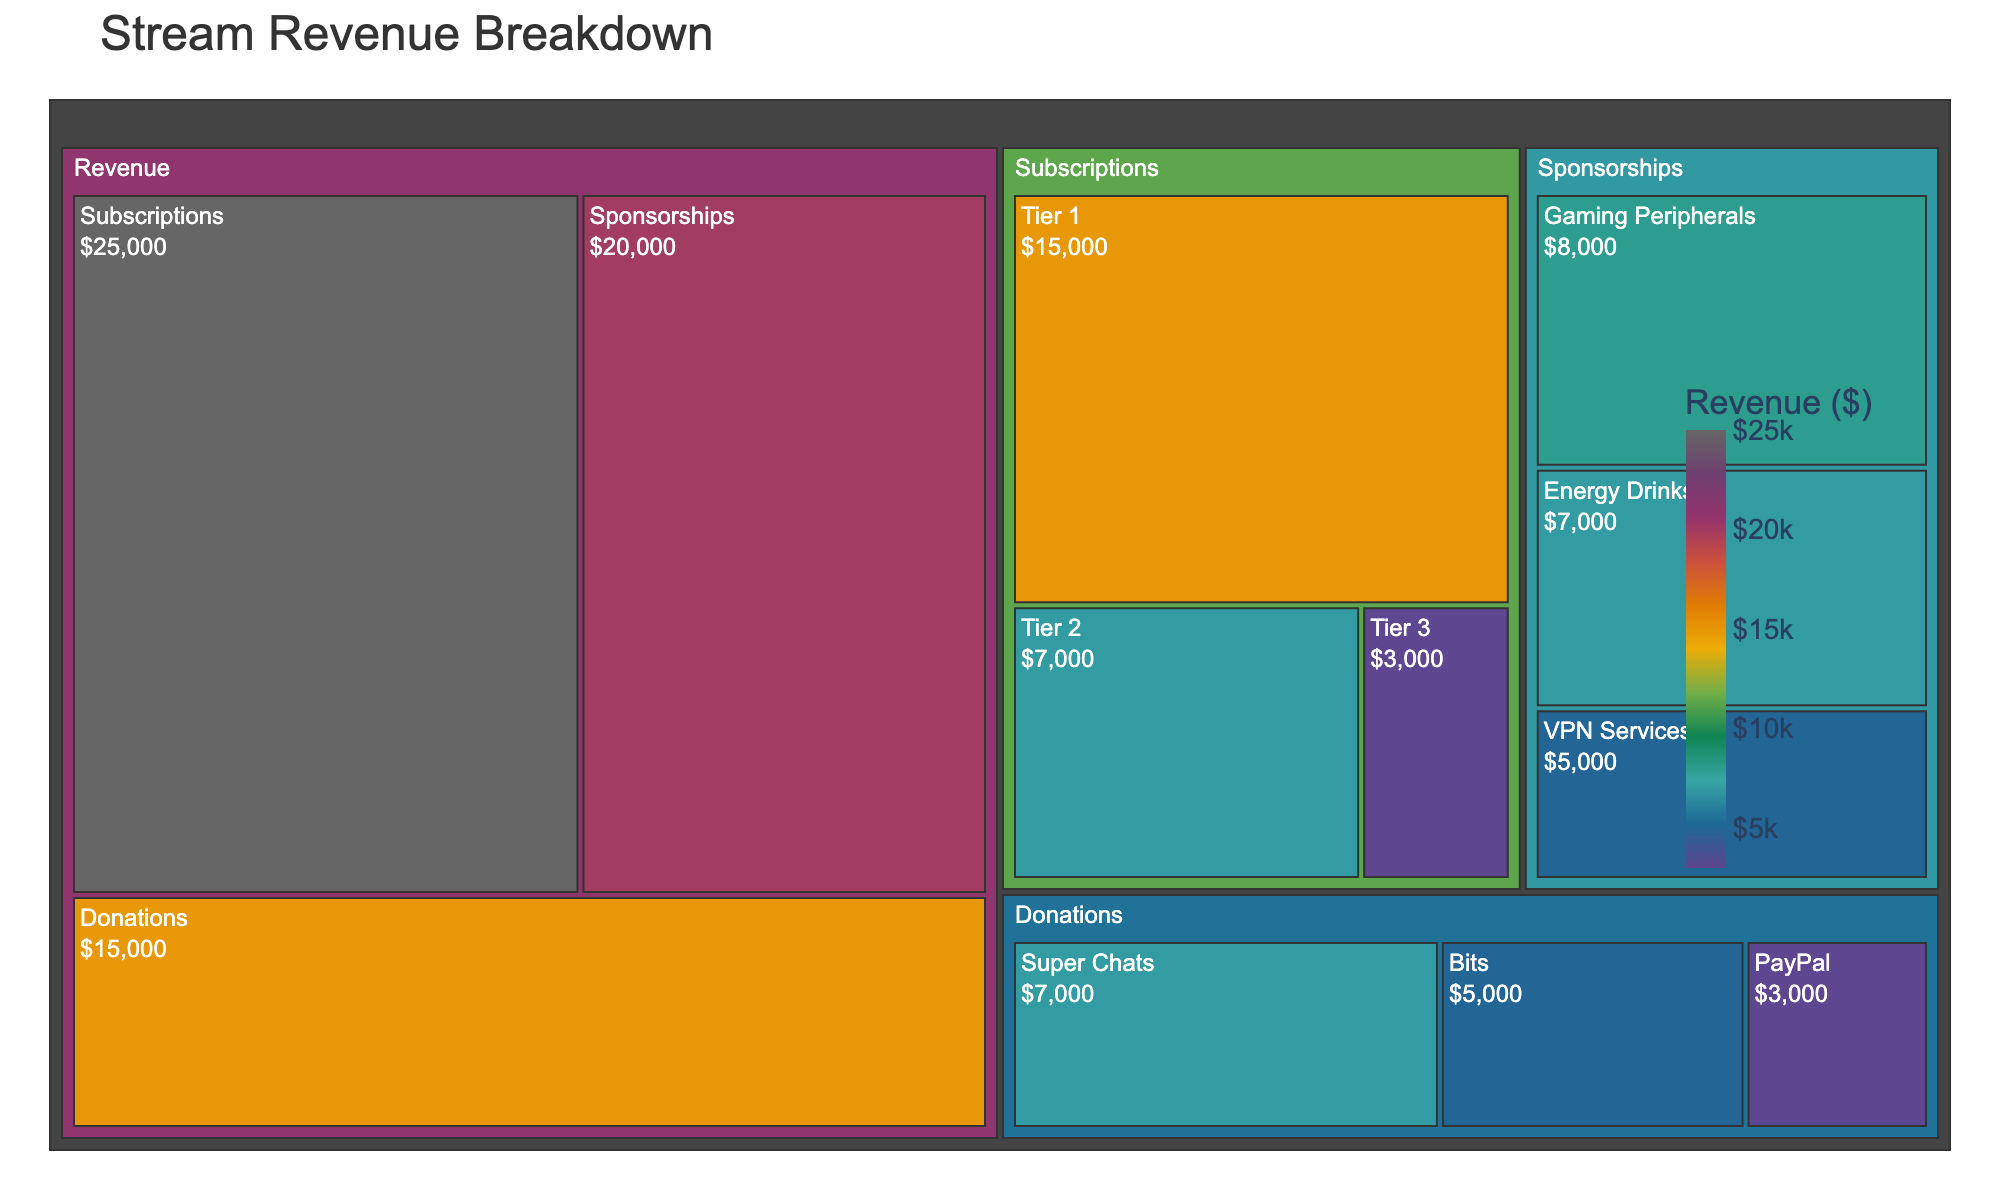What is the total revenue from Donations? The total revenue from Donations is the sum of Bits, Super Chats, and PayPal. Adding these gives 5000 + 7000 + 3000 = 15000.
Answer: 15000 Which category generates the highest revenue? Comparing Donations ($15000), Subscriptions ($25000), and Sponsorships ($20000), Subscriptions generate the highest revenue.
Answer: Subscriptions What is the combined revenue from Sponsorships and Subscriptions? The combined revenue is the sum of revenue from Sponsorships and Subscriptions. Adding 20000 + 25000 = 45000.
Answer: 45000 Among Donations' subcategories, which one provides the highest revenue? By looking at the values, Super Chats provide the highest revenue with $7000.
Answer: Super Chats How much more revenue do Subscriptions generate compared to Donations? Subscriptions generate $25000 and Donations generate $15000. The difference is calculated as 25000 - 15000 = 10000.
Answer: 10000 What is the average revenue of the subcategories under Sponsorships? Sponsorships have three subcategories: Gaming Peripherals ($8000), Energy Drinks ($7000), and VPN Services ($5000). The average is calculated as (8000 + 7000 + 5000)/3 = 20000/3 ≈ 6666.67.
Answer: 6666.67 Which has more revenue: Bits from Donations or Gaming Peripherals from Sponsorships? Bits generate $5000 while Gaming Peripherals generate $8000. Hence, Gaming Peripherals has more revenue.
Answer: Gaming Peripherals What percentage of total revenue comes from Subscriptions? The total revenue is 15000 (Donations) + 25000 (Subscriptions) + 20000 (Sponsorships) = 60000. The percentage from Subscriptions is (25000 / 60000) * 100 = 41.67%.
Answer: 41.67% What is the lowest revenue-generating subcategory in Donations? The subcategories under Donations are Bits ($5000), Super Chats ($7000), and PayPal ($3000). PayPal generates the lowest revenue.
Answer: PayPal 